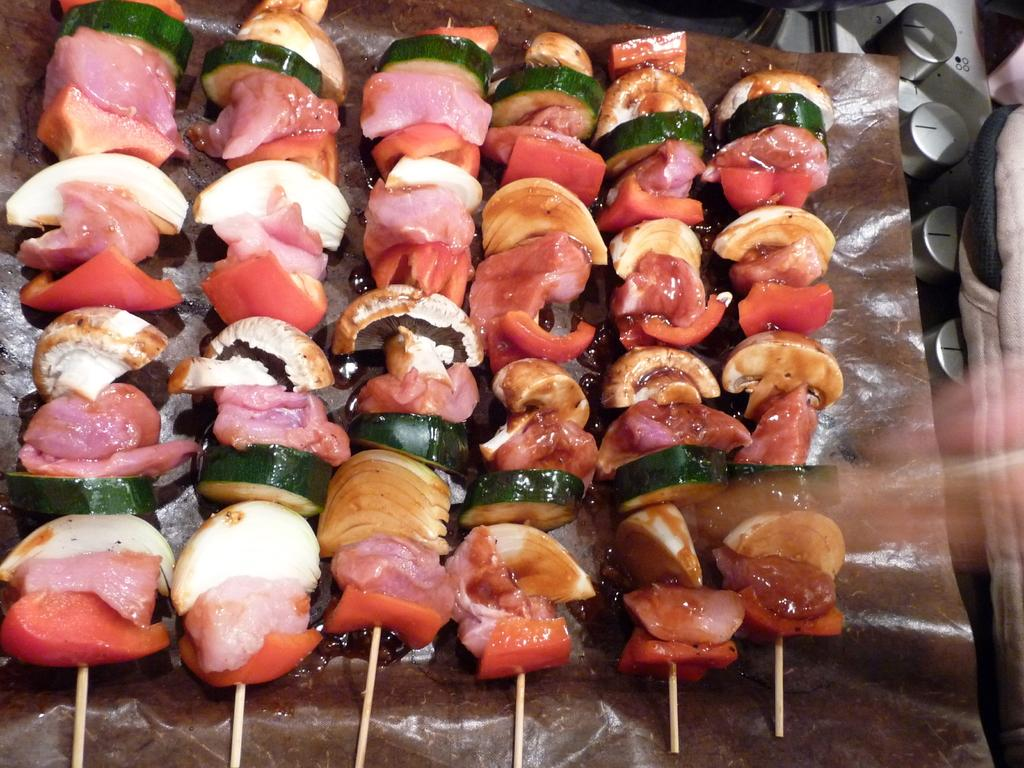What type of food is represented by the pieces in the image? The pieces in the image are vegetable pieces. How are the vegetable pieces arranged or displayed? The vegetable pieces are attached to small sticks and placed on a tray. What other objects can be seen in the image? Bottle caps are visible in the image. What type of face can be seen on the vegetable pieces in the image? There are no faces present on the vegetable pieces in the image. 